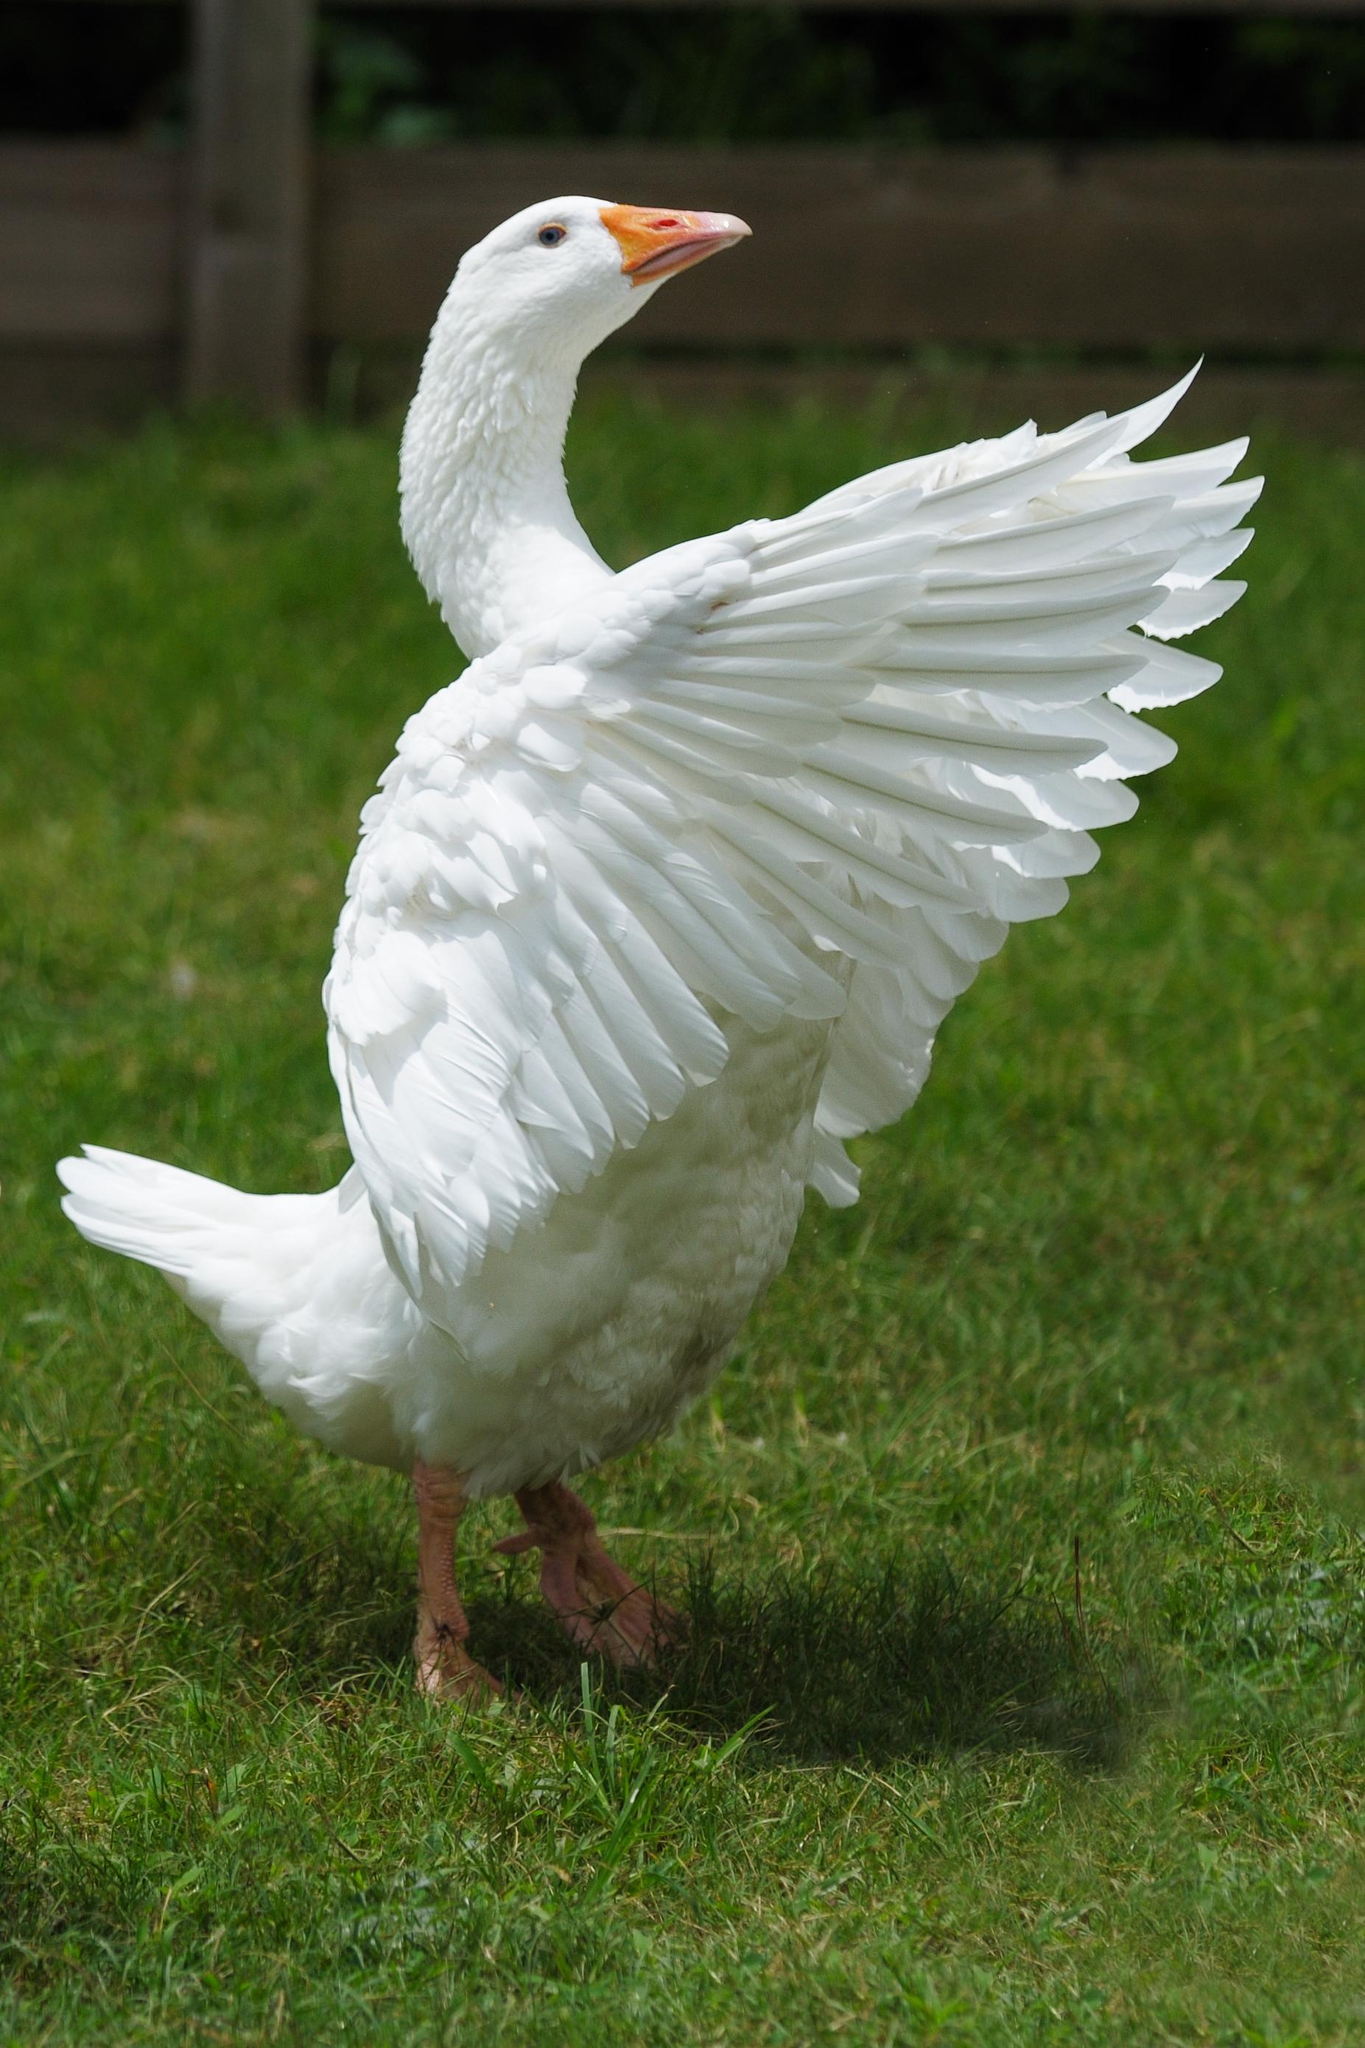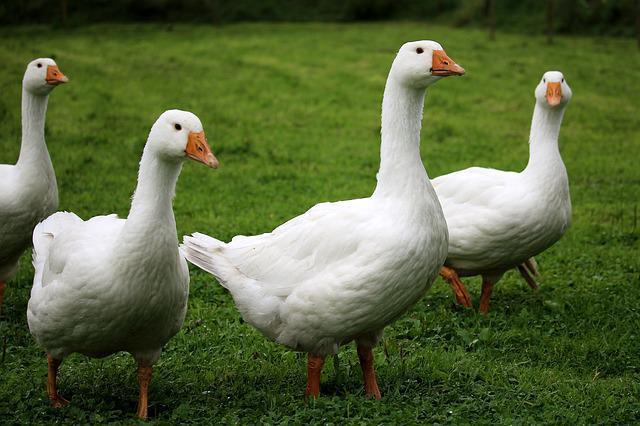The first image is the image on the left, the second image is the image on the right. Considering the images on both sides, is "There are more birds in the image on the left than in the image on the right." valid? Answer yes or no. No. The first image is the image on the left, the second image is the image on the right. Given the left and right images, does the statement "There are exactly three ducks in the left image." hold true? Answer yes or no. No. 